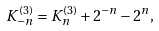Convert formula to latex. <formula><loc_0><loc_0><loc_500><loc_500>K _ { - n } ^ { ( 3 ) } = K _ { n } ^ { ( 3 ) } + 2 ^ { - n } - 2 ^ { n } ,</formula> 